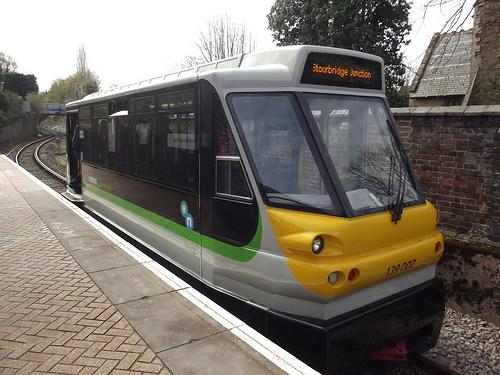Question: how many trains are shown?
Choices:
A. 2.
B. 3.
C. 1.
D. 4.
Answer with the letter. Answer: C Question: what is the platform made of?
Choices:
A. Wood.
B. Metal.
C. Brick.
D. Concrete.
Answer with the letter. Answer: C Question: what color is the train?
Choices:
A. Grey, yellow.
B. Blue and green.
C. Red and yellow.
D. Black and white.
Answer with the letter. Answer: A Question: what is the train stopped at?
Choices:
A. A road crossing.
B. A bridge.
C. Train station.
D. A railroad junction.
Answer with the letter. Answer: C Question: where is this shot?
Choices:
A. Staircase.
B. Ship.
C. Swimming pool.
D. Platform.
Answer with the letter. Answer: D 